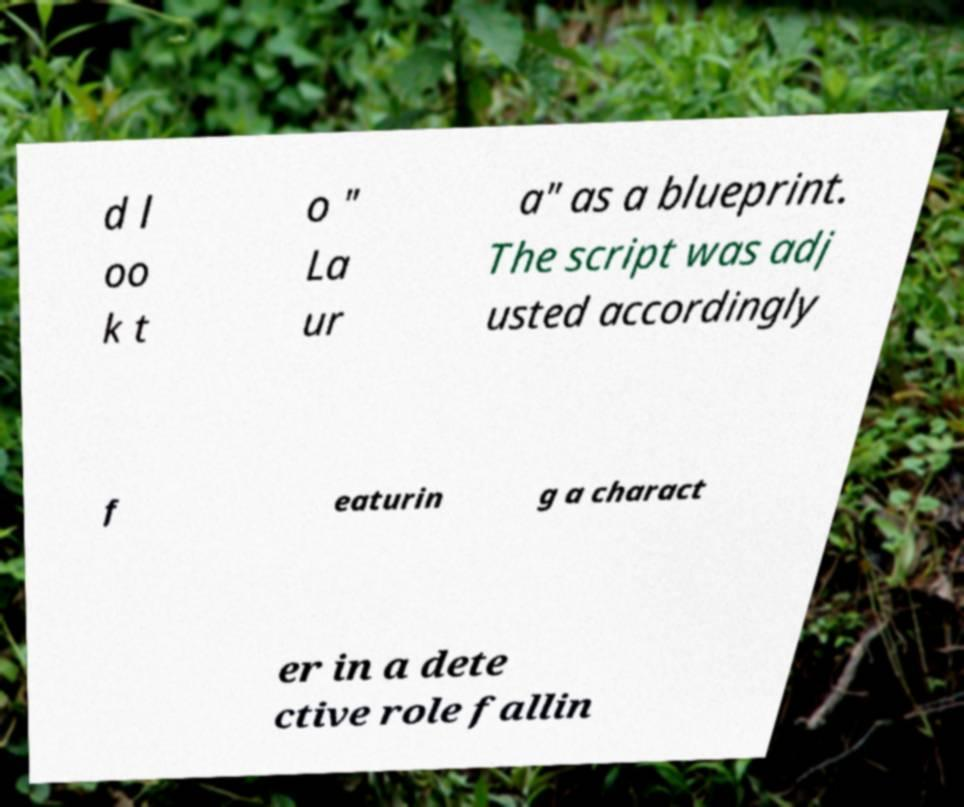Can you accurately transcribe the text from the provided image for me? d l oo k t o " La ur a" as a blueprint. The script was adj usted accordingly f eaturin g a charact er in a dete ctive role fallin 